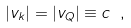<formula> <loc_0><loc_0><loc_500><loc_500>| { v } _ { k } | = | { v } _ { Q } | \equiv c \ ,</formula> 